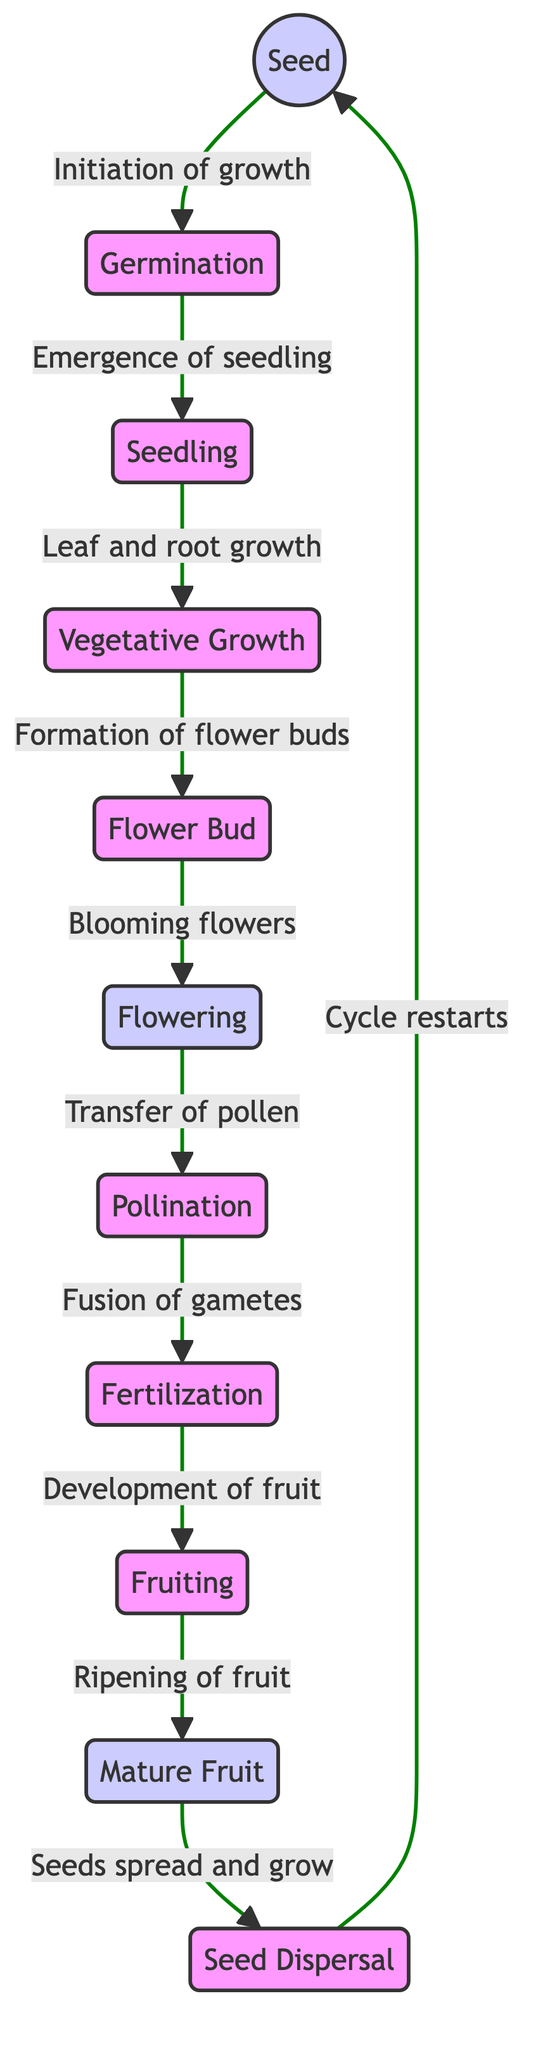What is the first stage in the lifecycle of a flower? The diagram indicates that the lifecycle starts with the "Seed." This is the first node in the flowchart, showing the initiation of the growth process.
Answer: Seed How many major stages are there in the lifecycle of a flower? By counting the distinct phases shown in the flowchart, there are 11 stages from "Seed" to "Seed Dispersal." Each stage represents a significant part of the flowering process.
Answer: 11 What happens after the "Flowering" stage? Referring to the flowchart, the next stage after "Flowering" is "Pollination." This indicates the transition from the blooming phase to the transfer of pollen, which is crucial for reproduction.
Answer: Pollination Which stage involves the fusion of gametes? In the diagram, "Fertilization" is identified as the stage where gametes fuse. This happens after "Pollination," indicating a crucial step in the reproductive process of flowering plants.
Answer: Fertilization What connects the "Budding" stage to the "Flowering" stage? The flowchart shows that "Budding" connects to "Flowering" through the indication of "Blooming flowers." This indicates a direct transition from the formation of buds to the opening of flowers.
Answer: Blooming flowers How does the lifecycle restart after reaching "Seed Dispersal"? According to the flowchart, the lifecycle restarts after "Seed Dispersal" with "Cycle restarts," meaning that the process begins again at the "Seed" stage after seeds spread and grow.
Answer: Cycle restarts What is the last stage before a flower matures into fruit? The diagram shows that after "Fruiting," the next stage is "Mature Fruit." This indicates that the fruit has fully developed and is ready for the next phase of seed dispersal.
Answer: Mature Fruit What links the "Vegetative Growth" stage to the "Budding" stage? The transition from "Vegetative Growth" to "Budding" is highlighted as "Formation of flower buds," indicating that this growth stage leads to the early formation of the flowers that will bloom.
Answer: Formation of flower buds What is the key process occurring during the "Pollination" stage? The diagram specifies that "Pollination" involves the "Transfer of pollen," which is the crucial process of moving pollen from one flower to another, enabling fertilization to occur.
Answer: Transfer of pollen 